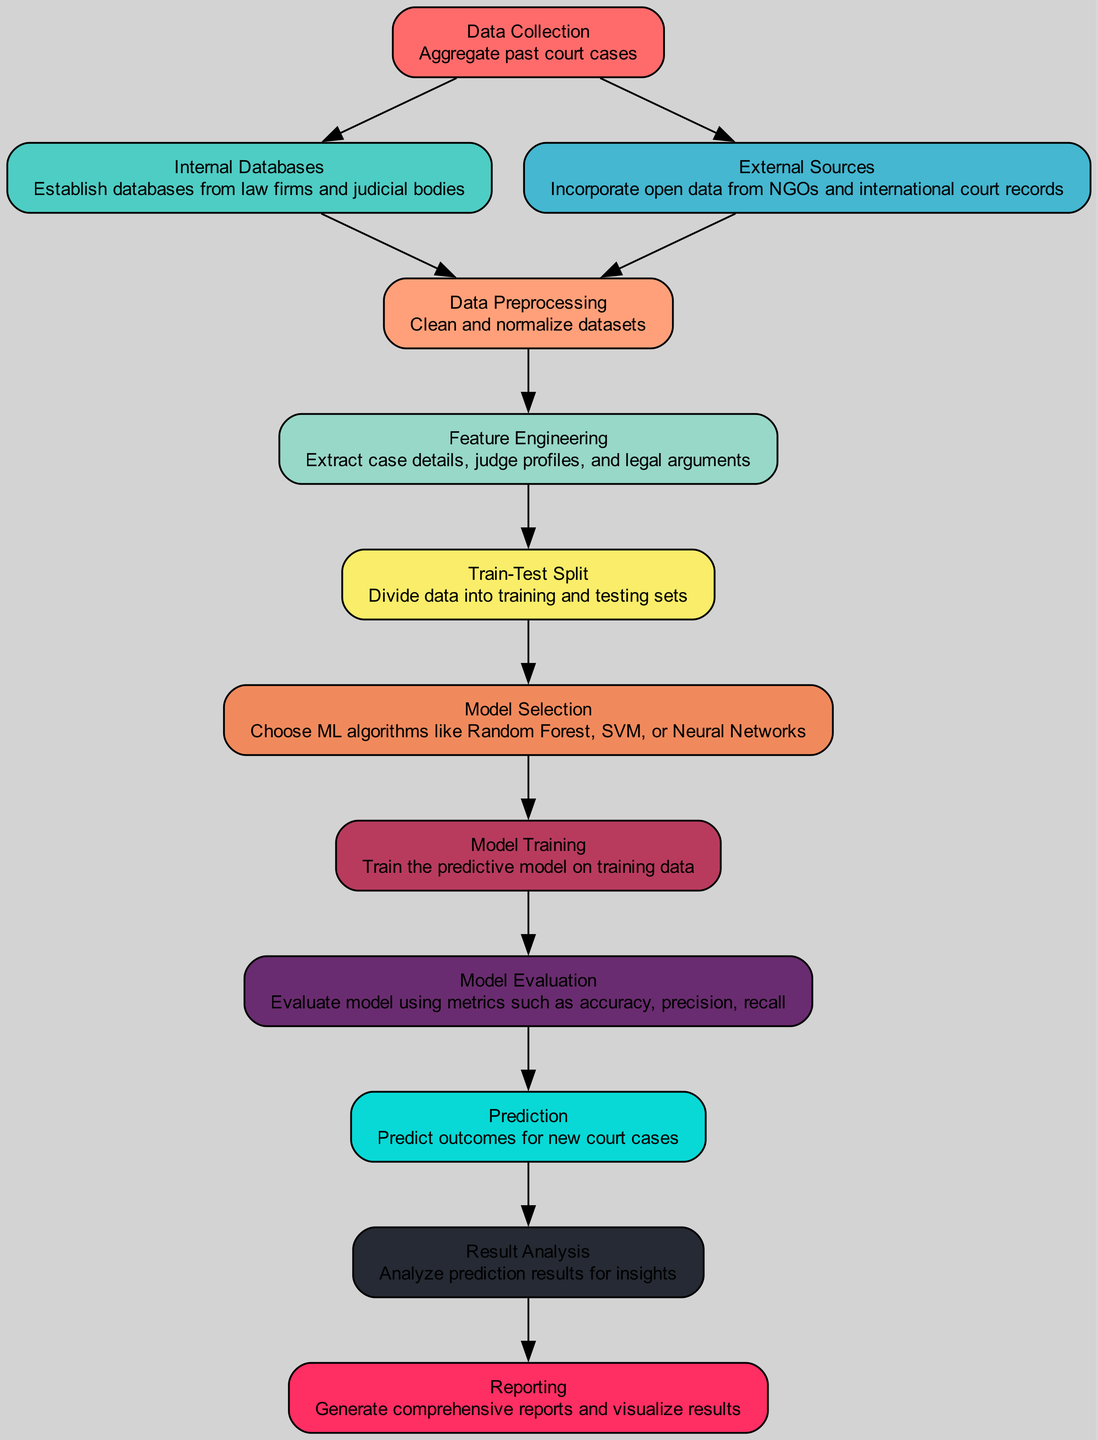What is the first step in the diagram? The first step is "Data Collection", which is the node that aggregates past court cases. This step is crucial as it sets the foundation for subsequent data processing.
Answer: Data Collection How many nodes are present in the diagram? By counting each labeled section in the diagram, we identify twelve distinct nodes, each corresponding to different steps in the predictive modeling process.
Answer: Twelve Which node follows "Data Preprocessing"? The node that follows "Data Preprocessing" is "Feature Engineering", which is responsible for extracting important details from the cleaned data, such as case specifics and judge profiles.
Answer: Feature Engineering What type of algorithms are considered in the "Model Selection" node? The "Model Selection" node considers algorithms such as Random Forest, Support Vector Machines, or Neural Networks, which are classic choices in machine learning for predictive tasks.
Answer: Random Forest, SVM, Neural Networks How does "Prediction" connect to the "Result Analysis" node? The connection between "Prediction" and "Result Analysis" establishes that once predictions are made on new court cases, the results are then analyzed for insights and understanding of the model's performance.
Answer: By a directed edge Which step requires evaluating metrics like accuracy and precision? The "Model Evaluation" step focuses on assessing the predictive model's performance using metrics such as accuracy, precision, and recall to ensure its reliability.
Answer: Model Evaluation Which node handles the generation of reports and visualization of results? The "Reporting" node is responsible for generating comprehensive reports and visualizing the results of the predictions, making insights accessible and understandable to users.
Answer: Reporting What is needed before "Model Training" can occur? Before "Model Training" takes place, it is essential to perform "Train-Test Split" to divide the processed data into training and testing sets for effective training and evaluation.
Answer: Train-Test Split What does the edge between "External Sources" and "Data Preprocessing" signify? The edge indicates that data obtained from external sources, such as NGOs and international court records, must be processed and cleaned alongside data from internal databases before it can be used for feature engineering.
Answer: Data integration for preprocessing 